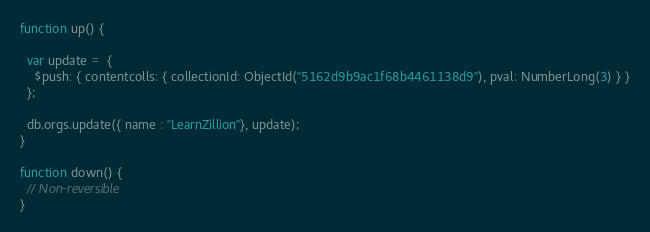Convert code to text. <code><loc_0><loc_0><loc_500><loc_500><_JavaScript_>function up() {

  var update =  {
    $push: { contentcolls: { collectionId: ObjectId("5162d9b9ac1f68b4461138d9"), pval: NumberLong(3) } }
  };

  db.orgs.update({ name : "LearnZillion"}, update);
}

function down() {
  // Non-reversible
}</code> 